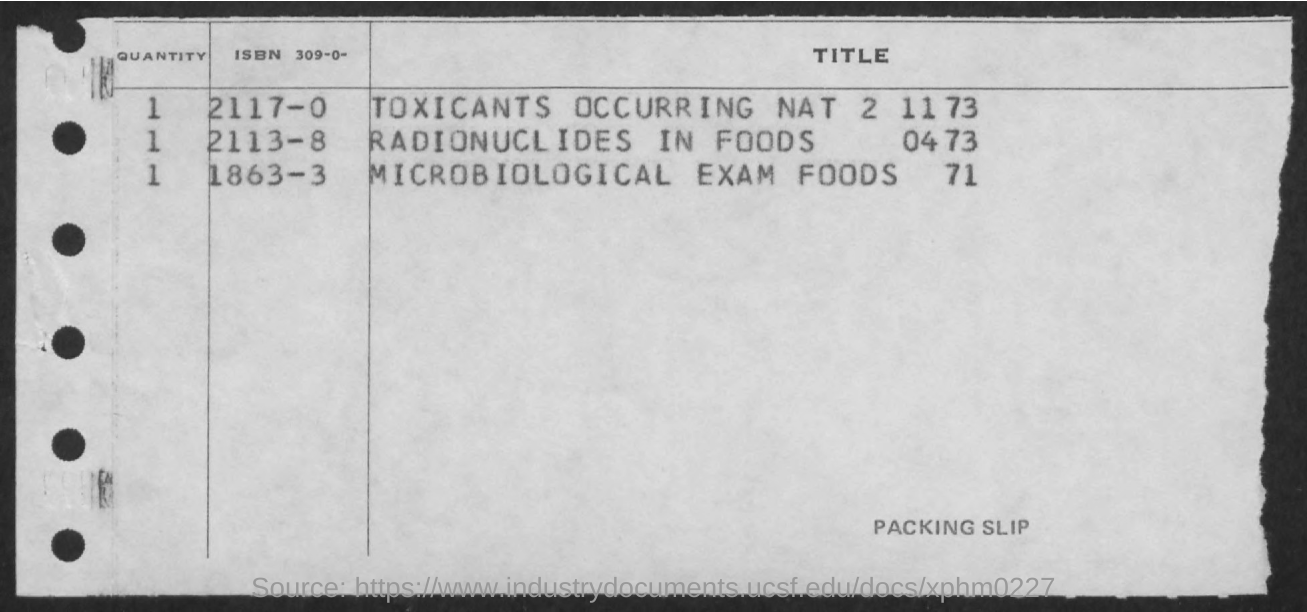Indicate a few pertinent items in this graphic. It is a packing slip. The heading of the first column is 'quantity'. The title for ISBN 2117-0 is "Toxicants Occurring Naturally in the Environment: Volume 2117". 